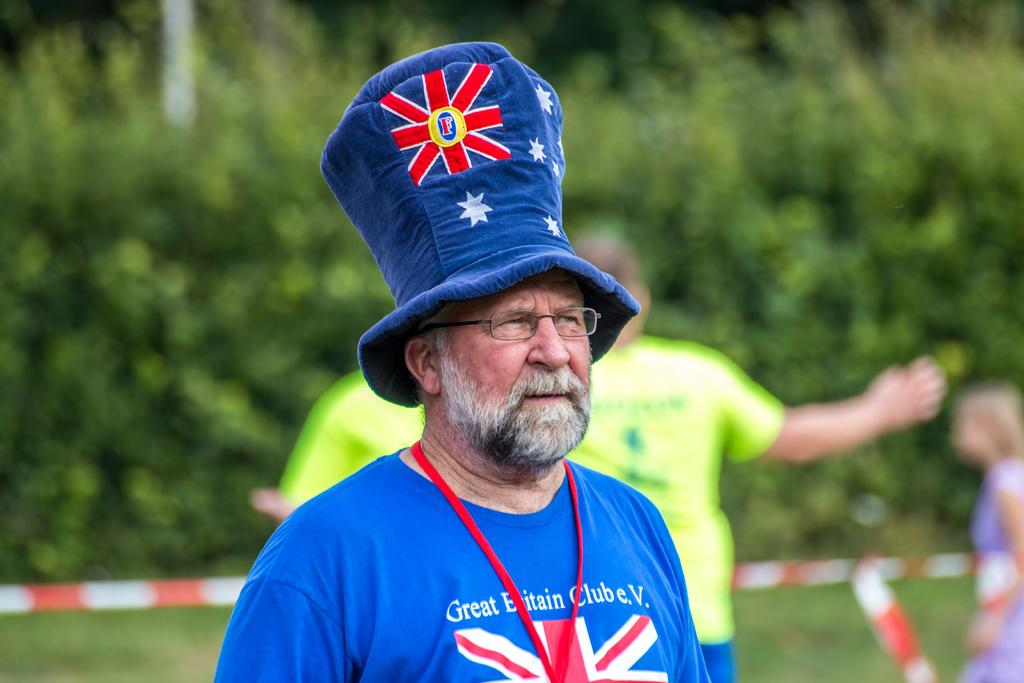<image>
Relay a brief, clear account of the picture shown. A man wearing a blue cap and blue shirt that says Great Britain Club e.V. 